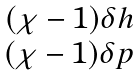Convert formula to latex. <formula><loc_0><loc_0><loc_500><loc_500>\begin{matrix} ( \chi - 1 ) \delta h \\ ( \chi - 1 ) \delta p \end{matrix}</formula> 